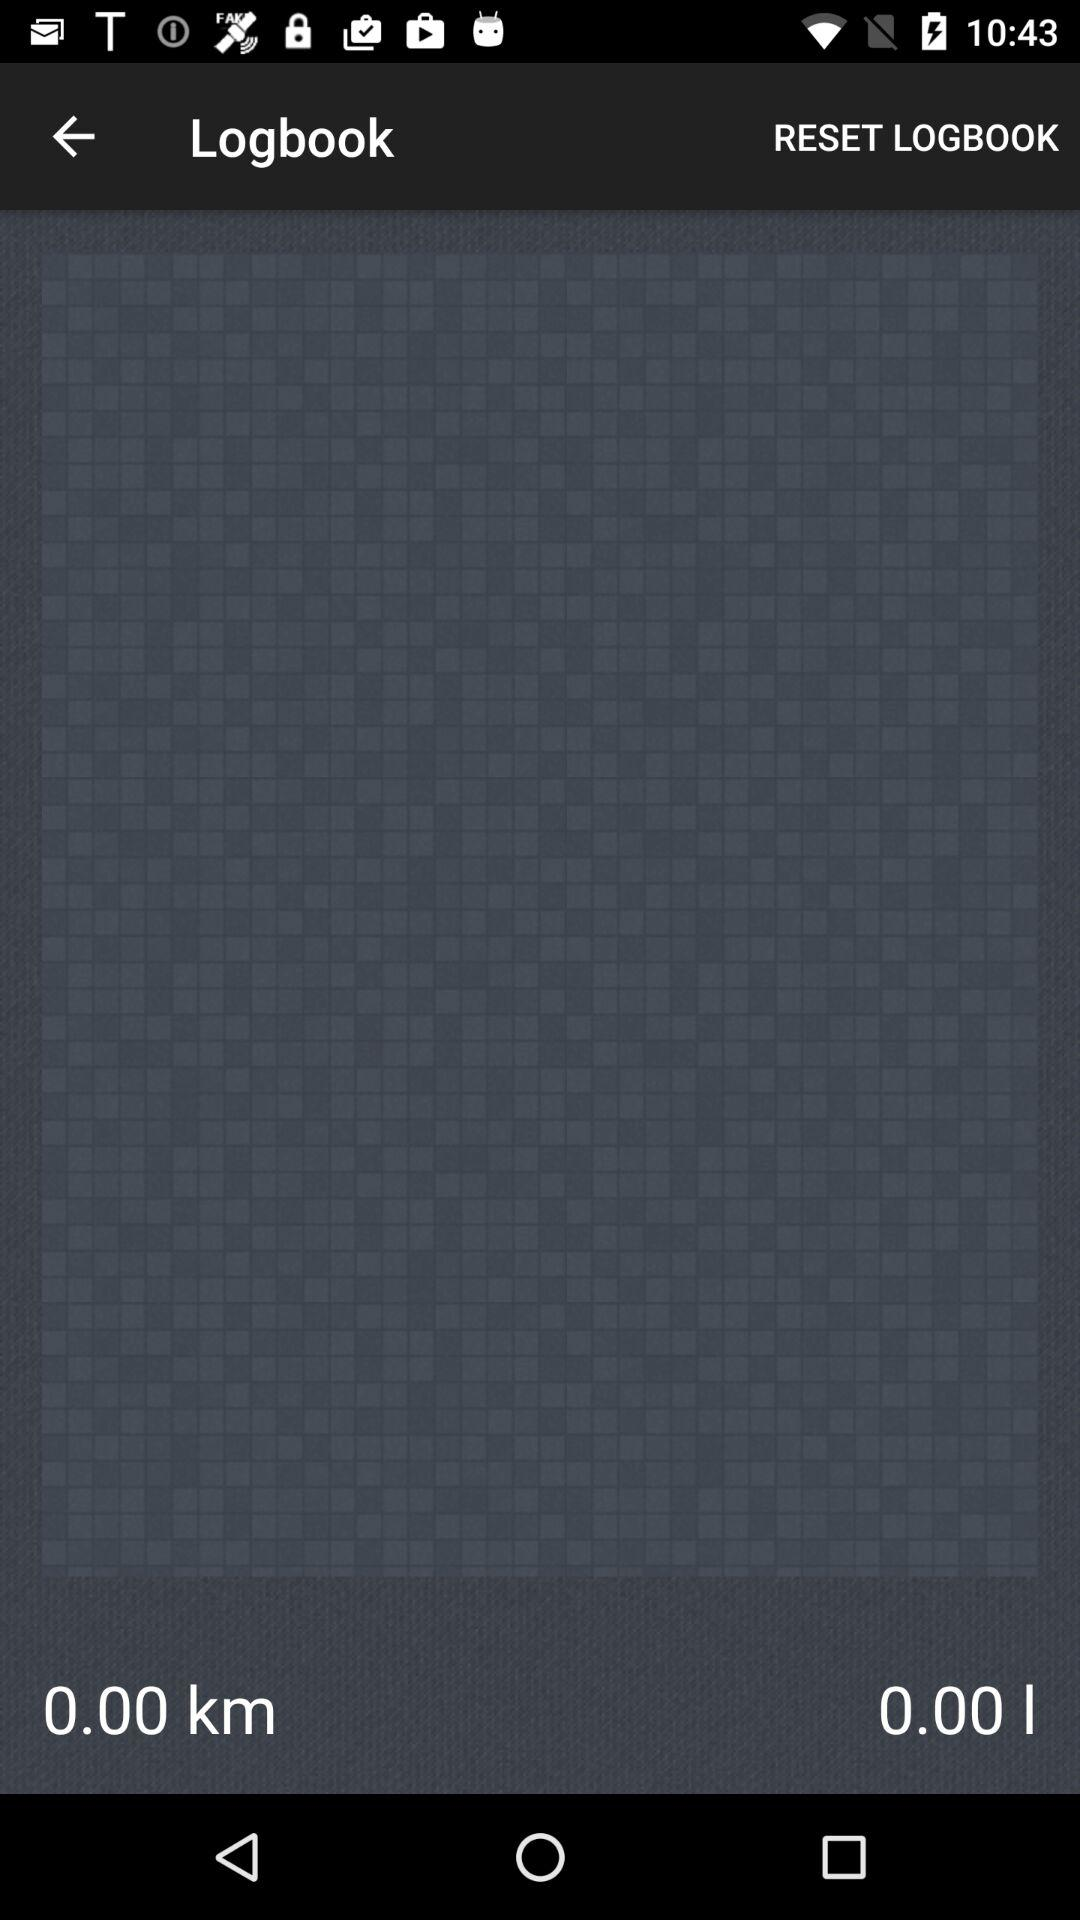How many litres are there? There are 0 litres. 